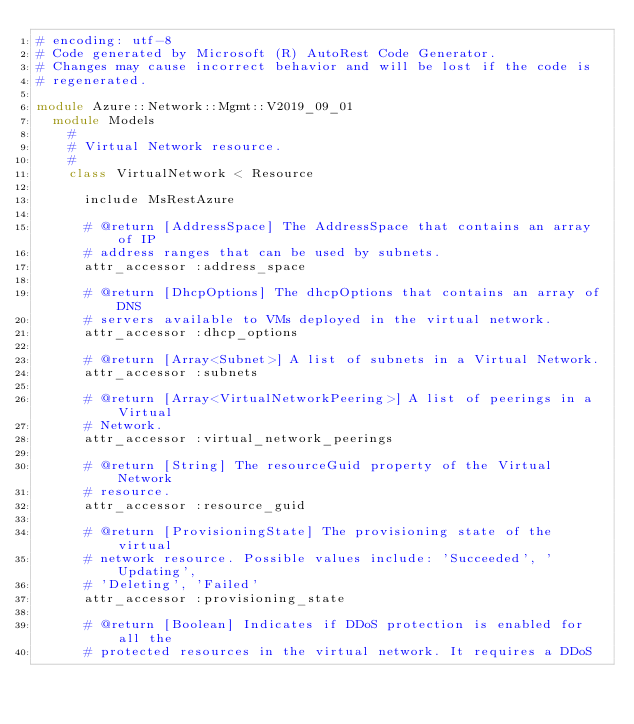Convert code to text. <code><loc_0><loc_0><loc_500><loc_500><_Ruby_># encoding: utf-8
# Code generated by Microsoft (R) AutoRest Code Generator.
# Changes may cause incorrect behavior and will be lost if the code is
# regenerated.

module Azure::Network::Mgmt::V2019_09_01
  module Models
    #
    # Virtual Network resource.
    #
    class VirtualNetwork < Resource

      include MsRestAzure

      # @return [AddressSpace] The AddressSpace that contains an array of IP
      # address ranges that can be used by subnets.
      attr_accessor :address_space

      # @return [DhcpOptions] The dhcpOptions that contains an array of DNS
      # servers available to VMs deployed in the virtual network.
      attr_accessor :dhcp_options

      # @return [Array<Subnet>] A list of subnets in a Virtual Network.
      attr_accessor :subnets

      # @return [Array<VirtualNetworkPeering>] A list of peerings in a Virtual
      # Network.
      attr_accessor :virtual_network_peerings

      # @return [String] The resourceGuid property of the Virtual Network
      # resource.
      attr_accessor :resource_guid

      # @return [ProvisioningState] The provisioning state of the virtual
      # network resource. Possible values include: 'Succeeded', 'Updating',
      # 'Deleting', 'Failed'
      attr_accessor :provisioning_state

      # @return [Boolean] Indicates if DDoS protection is enabled for all the
      # protected resources in the virtual network. It requires a DDoS</code> 